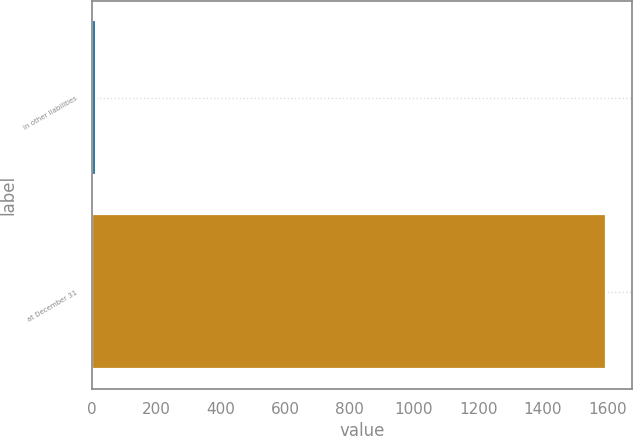Convert chart. <chart><loc_0><loc_0><loc_500><loc_500><bar_chart><fcel>in other liabilities<fcel>at December 31<nl><fcel>12<fcel>1596<nl></chart> 